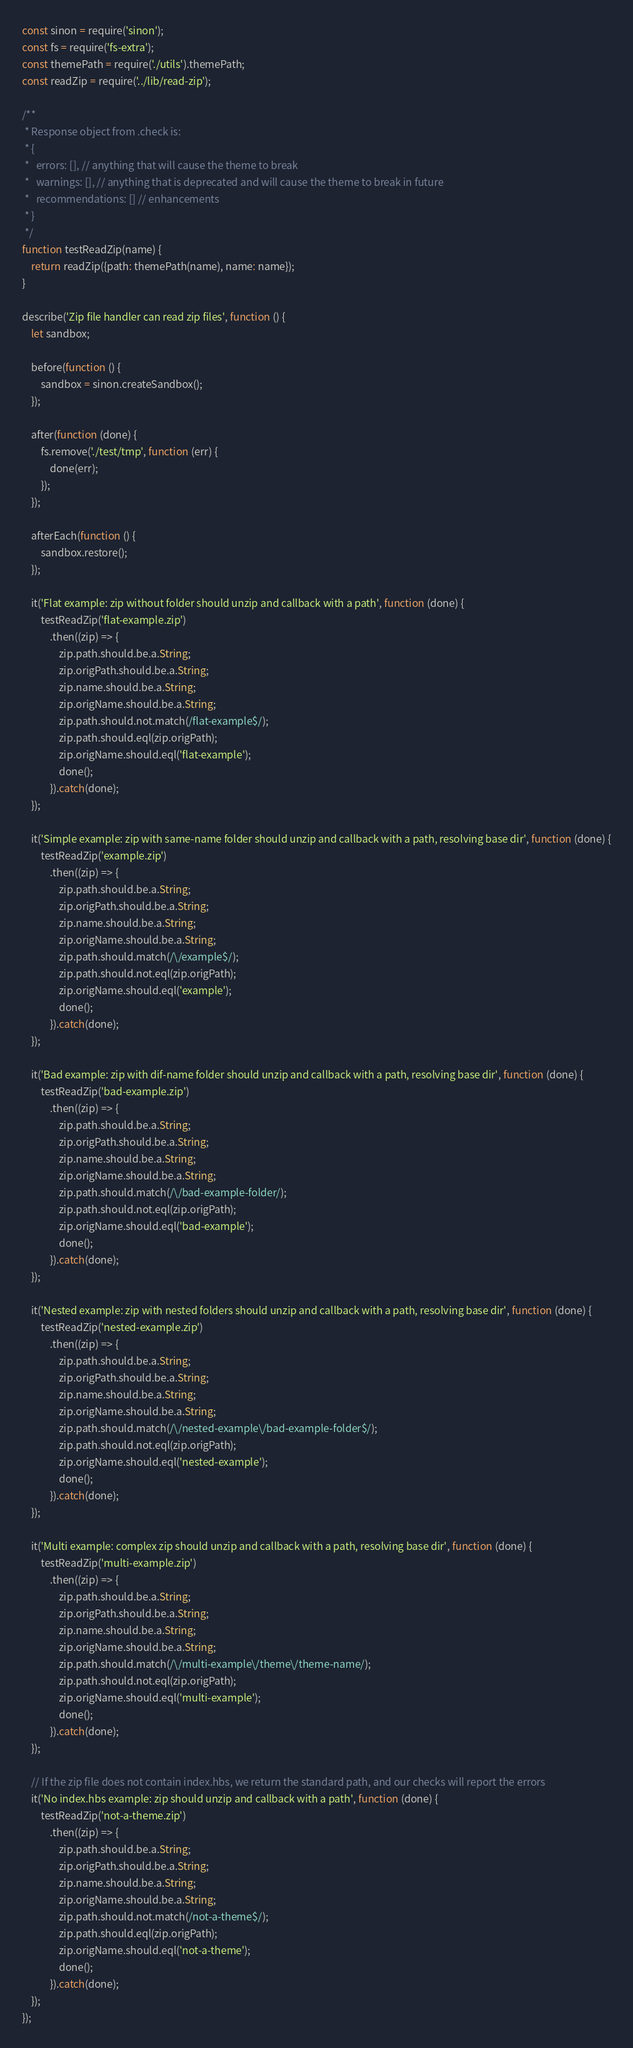Convert code to text. <code><loc_0><loc_0><loc_500><loc_500><_JavaScript_>const sinon = require('sinon');
const fs = require('fs-extra');
const themePath = require('./utils').themePath;
const readZip = require('../lib/read-zip');

/**
 * Response object from .check is:
 * {
 *   errors: [], // anything that will cause the theme to break
 *   warnings: [], // anything that is deprecated and will cause the theme to break in future
 *   recommendations: [] // enhancements
 * }
 */
function testReadZip(name) {
    return readZip({path: themePath(name), name: name});
}

describe('Zip file handler can read zip files', function () {
    let sandbox;

    before(function () {
        sandbox = sinon.createSandbox();
    });

    after(function (done) {
        fs.remove('./test/tmp', function (err) {
            done(err);
        });
    });

    afterEach(function () {
        sandbox.restore();
    });

    it('Flat example: zip without folder should unzip and callback with a path', function (done) {
        testReadZip('flat-example.zip')
            .then((zip) => {
                zip.path.should.be.a.String;
                zip.origPath.should.be.a.String;
                zip.name.should.be.a.String;
                zip.origName.should.be.a.String;
                zip.path.should.not.match(/flat-example$/);
                zip.path.should.eql(zip.origPath);
                zip.origName.should.eql('flat-example');
                done();
            }).catch(done);
    });

    it('Simple example: zip with same-name folder should unzip and callback with a path, resolving base dir', function (done) {
        testReadZip('example.zip')
            .then((zip) => {
                zip.path.should.be.a.String;
                zip.origPath.should.be.a.String;
                zip.name.should.be.a.String;
                zip.origName.should.be.a.String;
                zip.path.should.match(/\/example$/);
                zip.path.should.not.eql(zip.origPath);
                zip.origName.should.eql('example');
                done();
            }).catch(done);
    });

    it('Bad example: zip with dif-name folder should unzip and callback with a path, resolving base dir', function (done) {
        testReadZip('bad-example.zip')
            .then((zip) => {
                zip.path.should.be.a.String;
                zip.origPath.should.be.a.String;
                zip.name.should.be.a.String;
                zip.origName.should.be.a.String;
                zip.path.should.match(/\/bad-example-folder/);
                zip.path.should.not.eql(zip.origPath);
                zip.origName.should.eql('bad-example');
                done();
            }).catch(done);
    });

    it('Nested example: zip with nested folders should unzip and callback with a path, resolving base dir', function (done) {
        testReadZip('nested-example.zip')
            .then((zip) => {
                zip.path.should.be.a.String;
                zip.origPath.should.be.a.String;
                zip.name.should.be.a.String;
                zip.origName.should.be.a.String;
                zip.path.should.match(/\/nested-example\/bad-example-folder$/);
                zip.path.should.not.eql(zip.origPath);
                zip.origName.should.eql('nested-example');
                done();
            }).catch(done);
    });

    it('Multi example: complex zip should unzip and callback with a path, resolving base dir', function (done) {
        testReadZip('multi-example.zip')
            .then((zip) => {
                zip.path.should.be.a.String;
                zip.origPath.should.be.a.String;
                zip.name.should.be.a.String;
                zip.origName.should.be.a.String;
                zip.path.should.match(/\/multi-example\/theme\/theme-name/);
                zip.path.should.not.eql(zip.origPath);
                zip.origName.should.eql('multi-example');
                done();
            }).catch(done);
    });

    // If the zip file does not contain index.hbs, we return the standard path, and our checks will report the errors
    it('No index.hbs example: zip should unzip and callback with a path', function (done) {
        testReadZip('not-a-theme.zip')
            .then((zip) => {
                zip.path.should.be.a.String;
                zip.origPath.should.be.a.String;
                zip.name.should.be.a.String;
                zip.origName.should.be.a.String;
                zip.path.should.not.match(/not-a-theme$/);
                zip.path.should.eql(zip.origPath);
                zip.origName.should.eql('not-a-theme');
                done();
            }).catch(done);
    });
});
</code> 